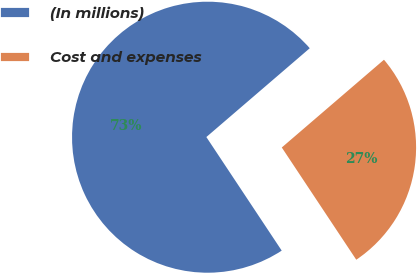Convert chart to OTSL. <chart><loc_0><loc_0><loc_500><loc_500><pie_chart><fcel>(In millions)<fcel>Cost and expenses<nl><fcel>73.03%<fcel>26.97%<nl></chart> 